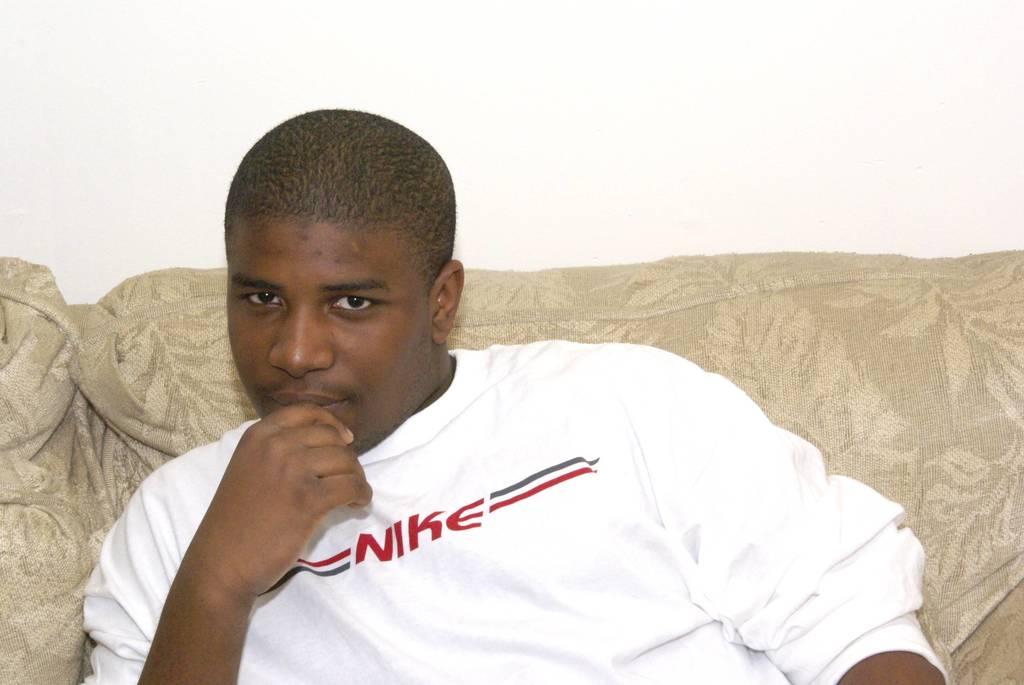What does the t-shirt say?
Provide a succinct answer. Nike. 